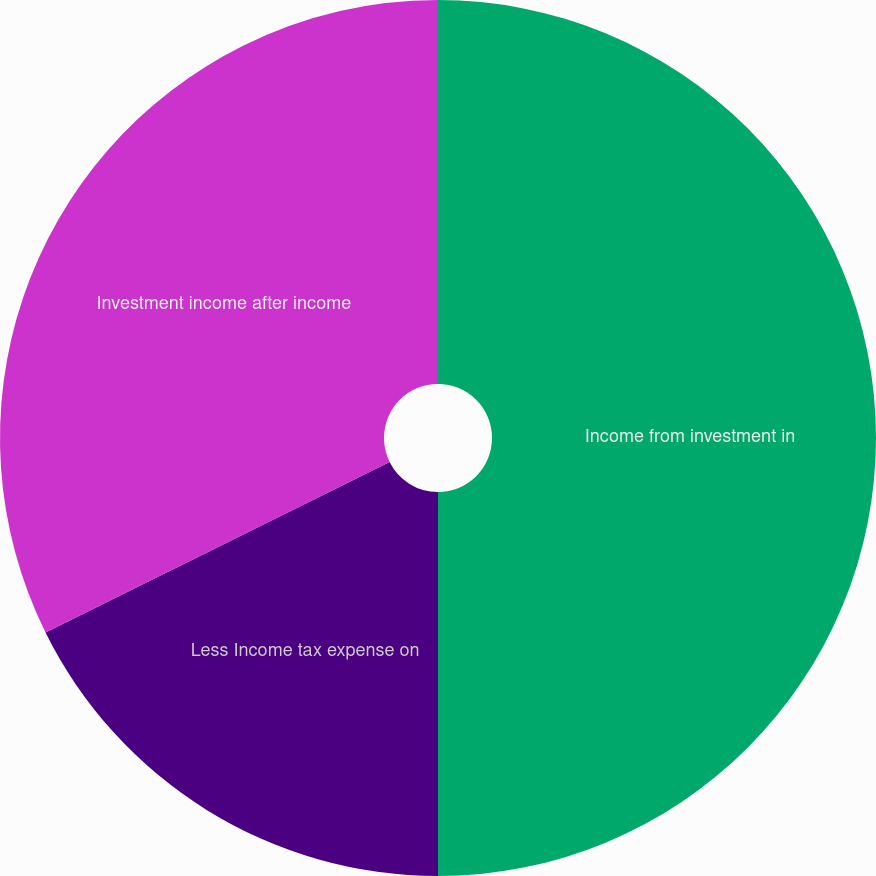<chart> <loc_0><loc_0><loc_500><loc_500><pie_chart><fcel>Income from investment in<fcel>Less Income tax expense on<fcel>Investment income after income<nl><fcel>50.0%<fcel>17.68%<fcel>32.32%<nl></chart> 